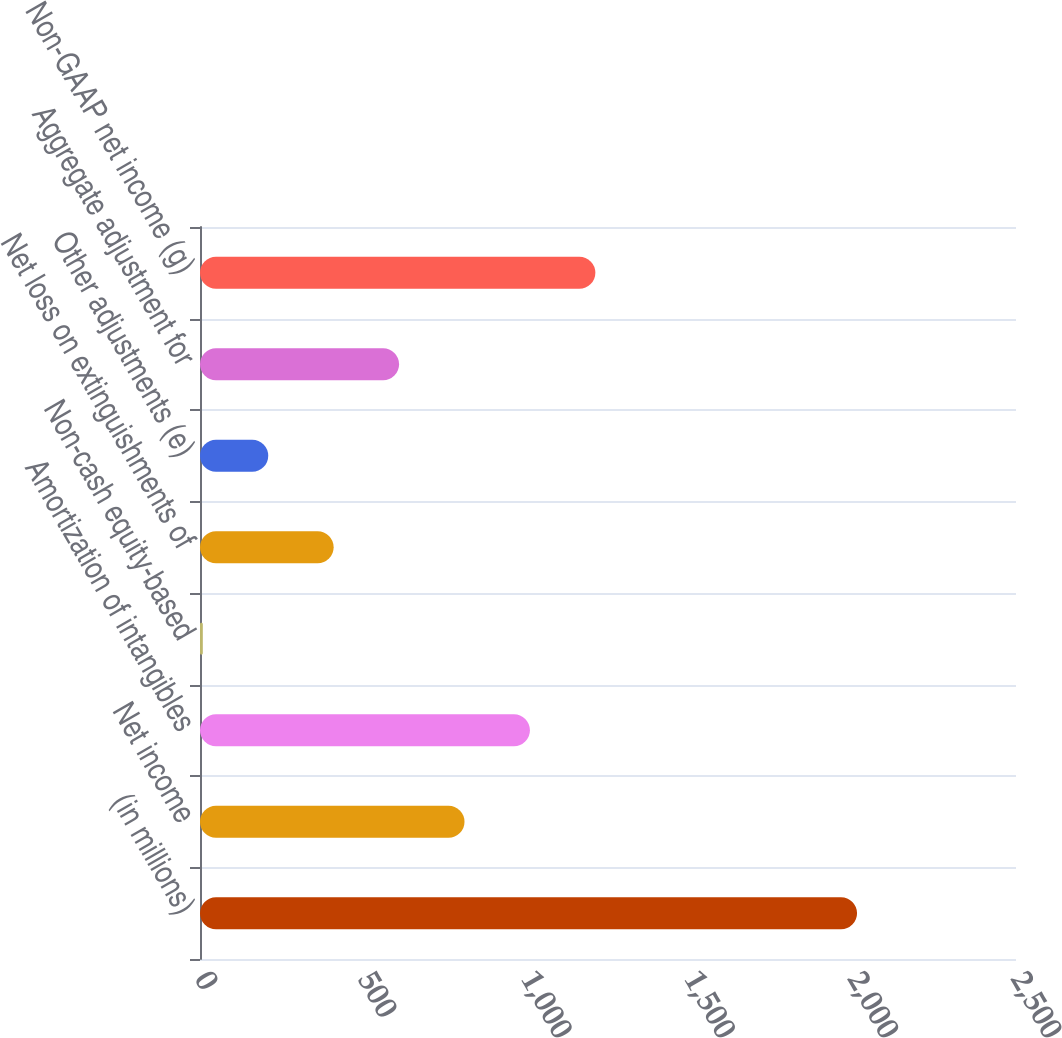<chart> <loc_0><loc_0><loc_500><loc_500><bar_chart><fcel>(in millions)<fcel>Net income<fcel>Amortization of intangibles<fcel>Non-cash equity-based<fcel>Net loss on extinguishments of<fcel>Other adjustments (e)<fcel>Aggregate adjustment for<fcel>Non-GAAP net income (g)<nl><fcel>2013<fcel>810.36<fcel>1010.8<fcel>8.6<fcel>409.48<fcel>209.04<fcel>609.92<fcel>1211.24<nl></chart> 